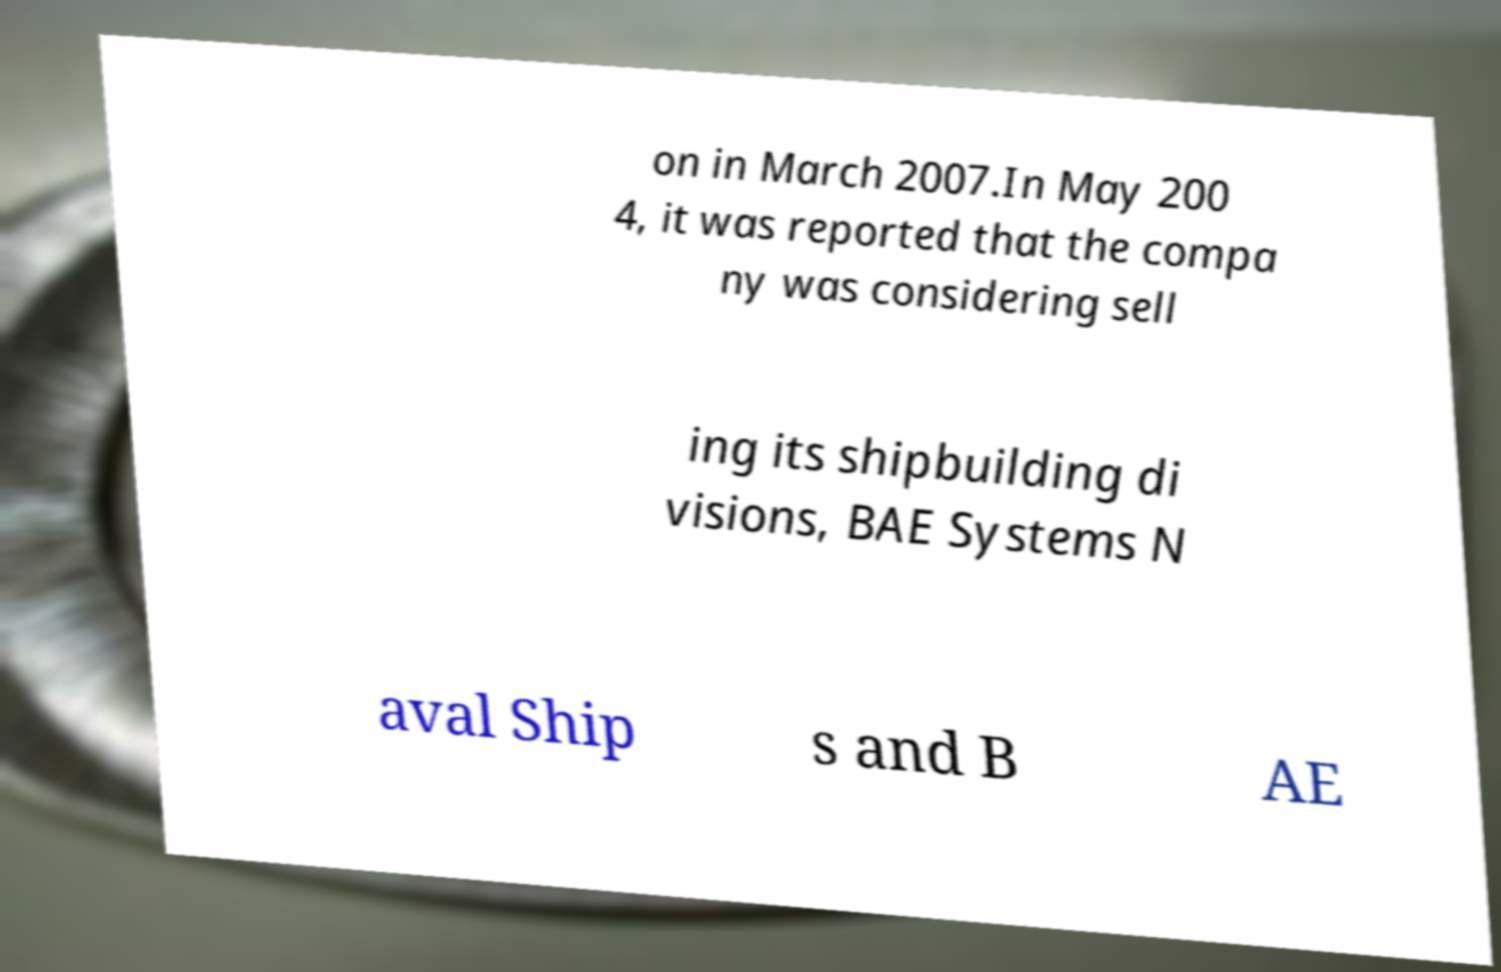Can you read and provide the text displayed in the image?This photo seems to have some interesting text. Can you extract and type it out for me? on in March 2007.In May 200 4, it was reported that the compa ny was considering sell ing its shipbuilding di visions, BAE Systems N aval Ship s and B AE 